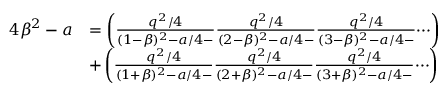<formula> <loc_0><loc_0><loc_500><loc_500>\begin{array} { r l } { 4 \beta ^ { 2 } - a } & { = \left ( \frac { q ^ { 2 } / 4 } { ( 1 - \beta ) ^ { 2 } - a / 4 - } \frac { q ^ { 2 } / 4 } { ( 2 - \beta ) ^ { 2 } - a / 4 - } \frac { q ^ { 2 } / 4 } { ( 3 - \beta ) ^ { 2 } - a / 4 - } \dots i \right ) } \\ & { + \left ( \frac { q ^ { 2 } / 4 } { ( 1 + \beta ) ^ { 2 } - a / 4 - } \frac { q ^ { 2 } / 4 } { ( 2 + \beta ) ^ { 2 } - a / 4 - } \frac { q ^ { 2 } / 4 } { ( 3 + \beta ) ^ { 2 } - a / 4 - } \dots i \right ) } \end{array}</formula> 